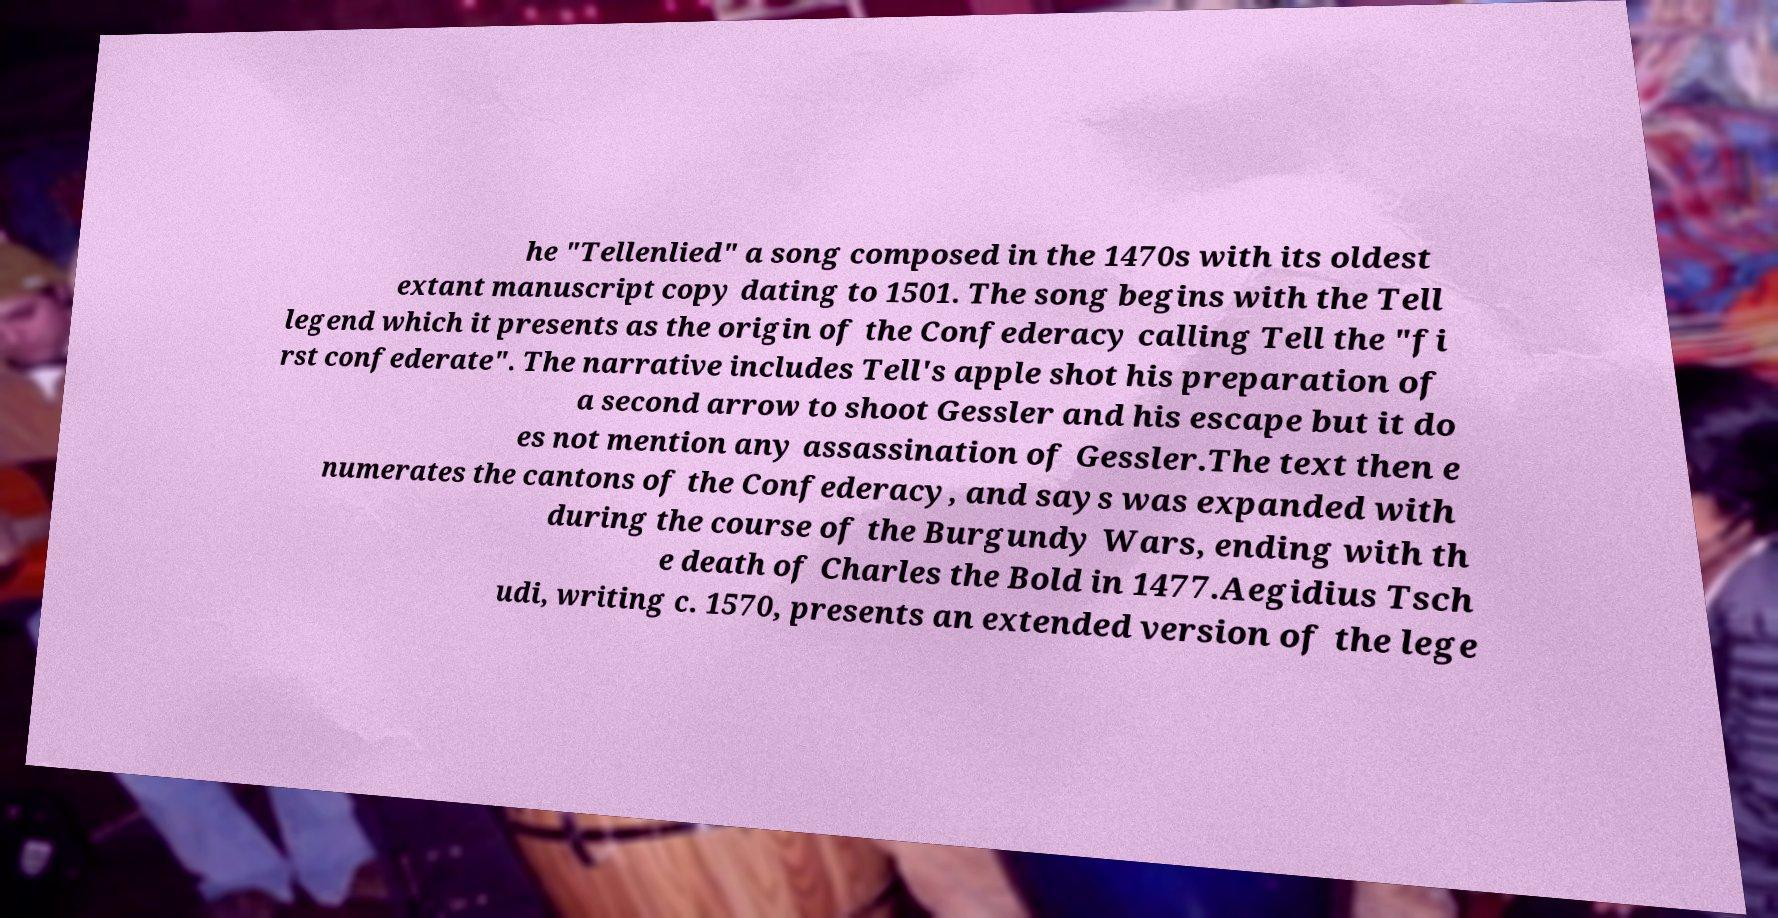Can you accurately transcribe the text from the provided image for me? he "Tellenlied" a song composed in the 1470s with its oldest extant manuscript copy dating to 1501. The song begins with the Tell legend which it presents as the origin of the Confederacy calling Tell the "fi rst confederate". The narrative includes Tell's apple shot his preparation of a second arrow to shoot Gessler and his escape but it do es not mention any assassination of Gessler.The text then e numerates the cantons of the Confederacy, and says was expanded with during the course of the Burgundy Wars, ending with th e death of Charles the Bold in 1477.Aegidius Tsch udi, writing c. 1570, presents an extended version of the lege 